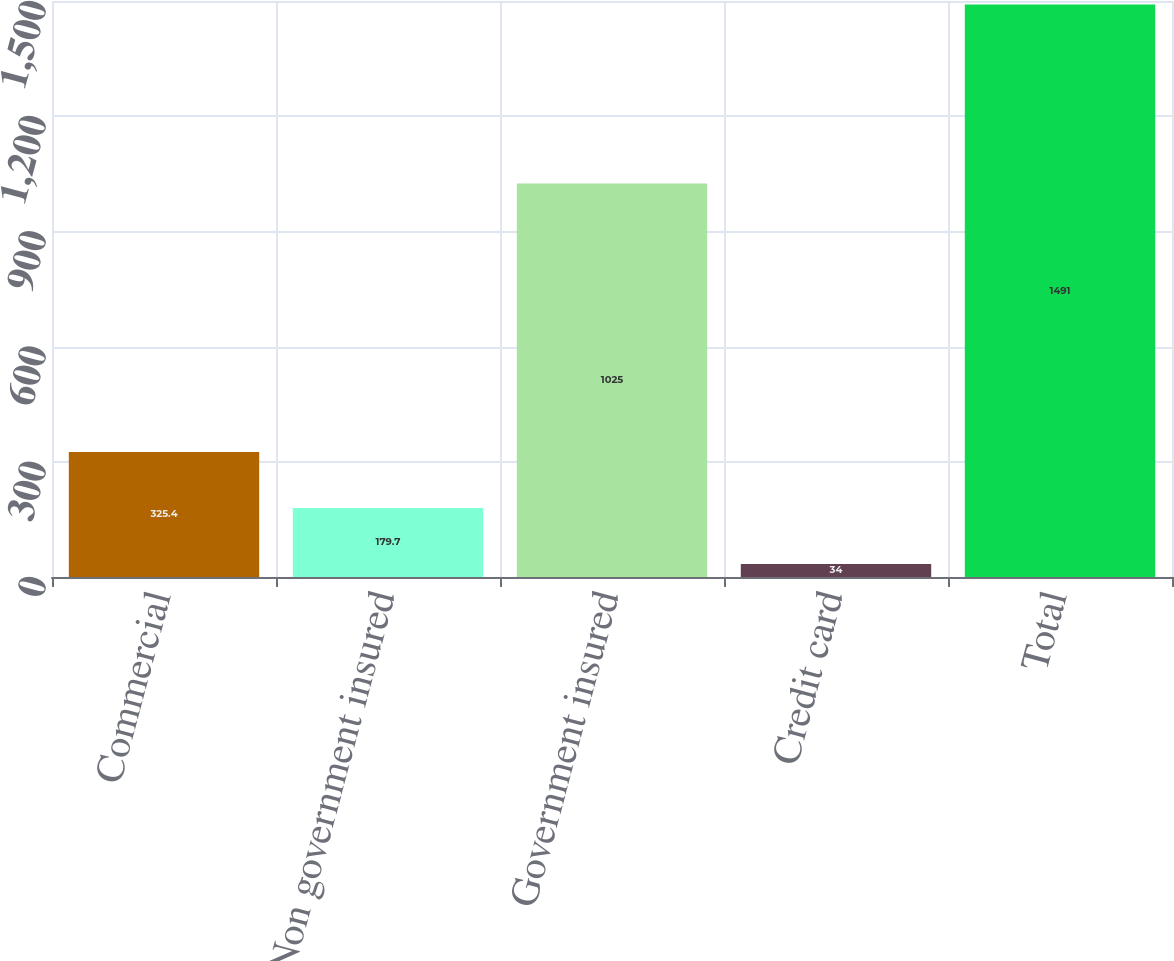Convert chart. <chart><loc_0><loc_0><loc_500><loc_500><bar_chart><fcel>Commercial<fcel>Non government insured<fcel>Government insured<fcel>Credit card<fcel>Total<nl><fcel>325.4<fcel>179.7<fcel>1025<fcel>34<fcel>1491<nl></chart> 